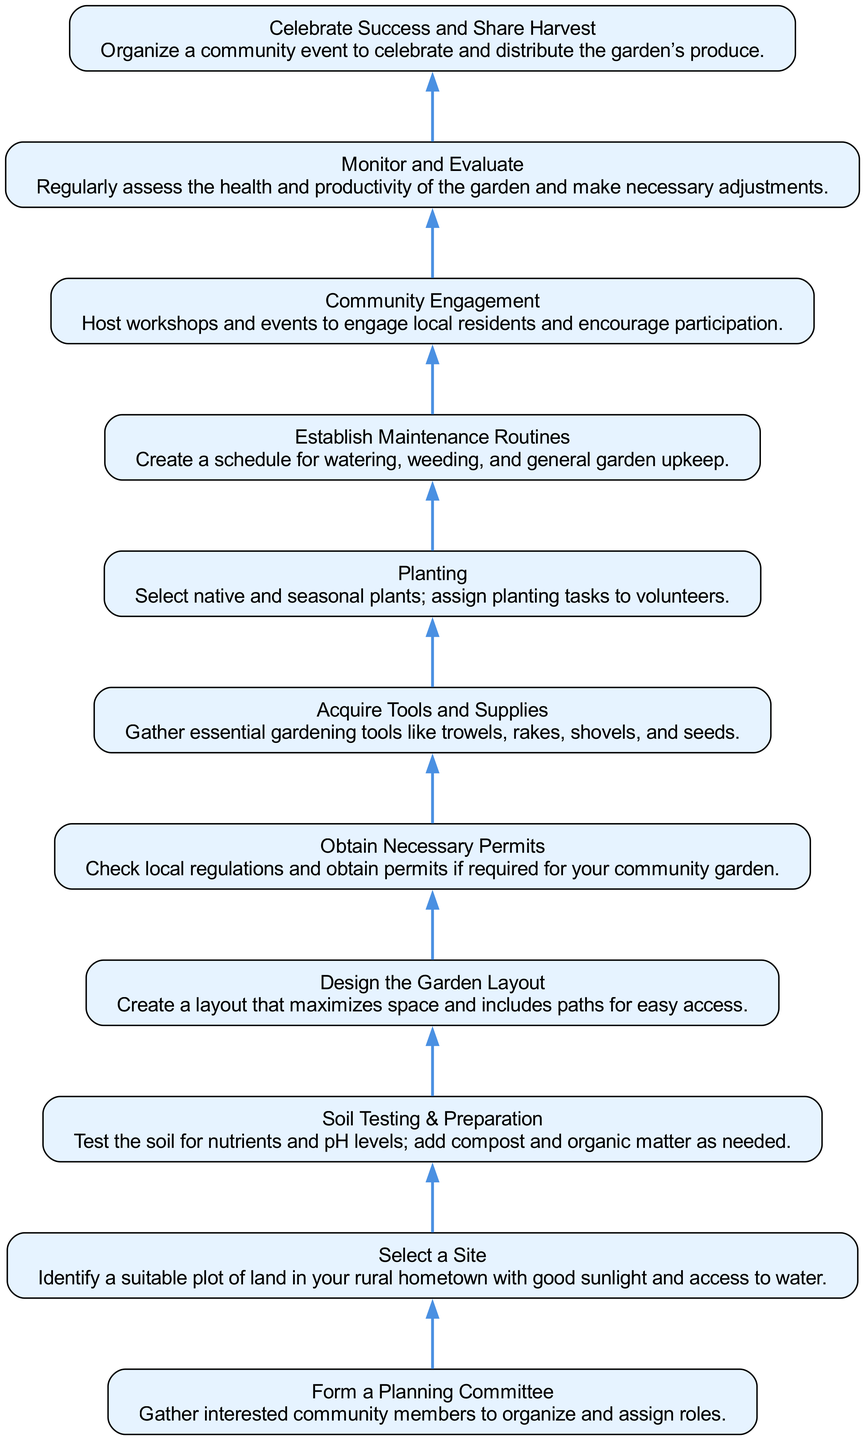What's the first step in the process? The diagram lists "Form a Planning Committee" as the first step, which is found at the bottom.
Answer: Form a Planning Committee How many total steps are there in the diagram? By counting all the steps from the bottom to the top in the diagram, including the final celebration step at the top, we find a total of 10 steps.
Answer: 10 What is the last step in the process? The last step listed at the top of the diagram is "Celebrate Success and Share Harvest."
Answer: Celebrate Success and Share Harvest Which step comes before "Obtain Necessary Permits"? In the flow, "Design the Garden Layout" is directly before "Obtain Necessary Permits," indicating it is the step preceding it.
Answer: Design the Garden Layout What are the two main activities listed under "Community Engagement"? The "Community Engagement" step mentions hosting workshops and events as the two activities to involve local residents.
Answer: Host workshops and events Why is "Soil Testing & Preparation" important before planting? "Soil Testing & Preparation" is crucial because it ensures the soil has adequate nutrients and pH levels necessary for healthy plant growth. This step is essential to set up for successful planting later on.
Answer: Nutrients and pH levels Between which two steps is "Planting" located? "Planting" is located between "Acquire Tools and Supplies" and "Establish Maintenance Routines," indicating it is conducted after gathering needed materials but before setting routines for upkeep.
Answer: Acquire Tools and Supplies and Establish Maintenance Routines What action follows "Monitor and Evaluate"? The action that follows "Monitor and Evaluate" is "Celebrate Success and Share Harvest," which signifies a celebration of what was achieved in the garden.
Answer: Celebrate Success and Share Harvest 